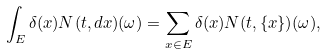Convert formula to latex. <formula><loc_0><loc_0><loc_500><loc_500>\int _ { E } \delta ( x ) N ( t , d x ) ( \omega ) = \sum _ { x \in E } \delta ( x ) N ( t , \{ x \} ) ( \omega ) ,</formula> 